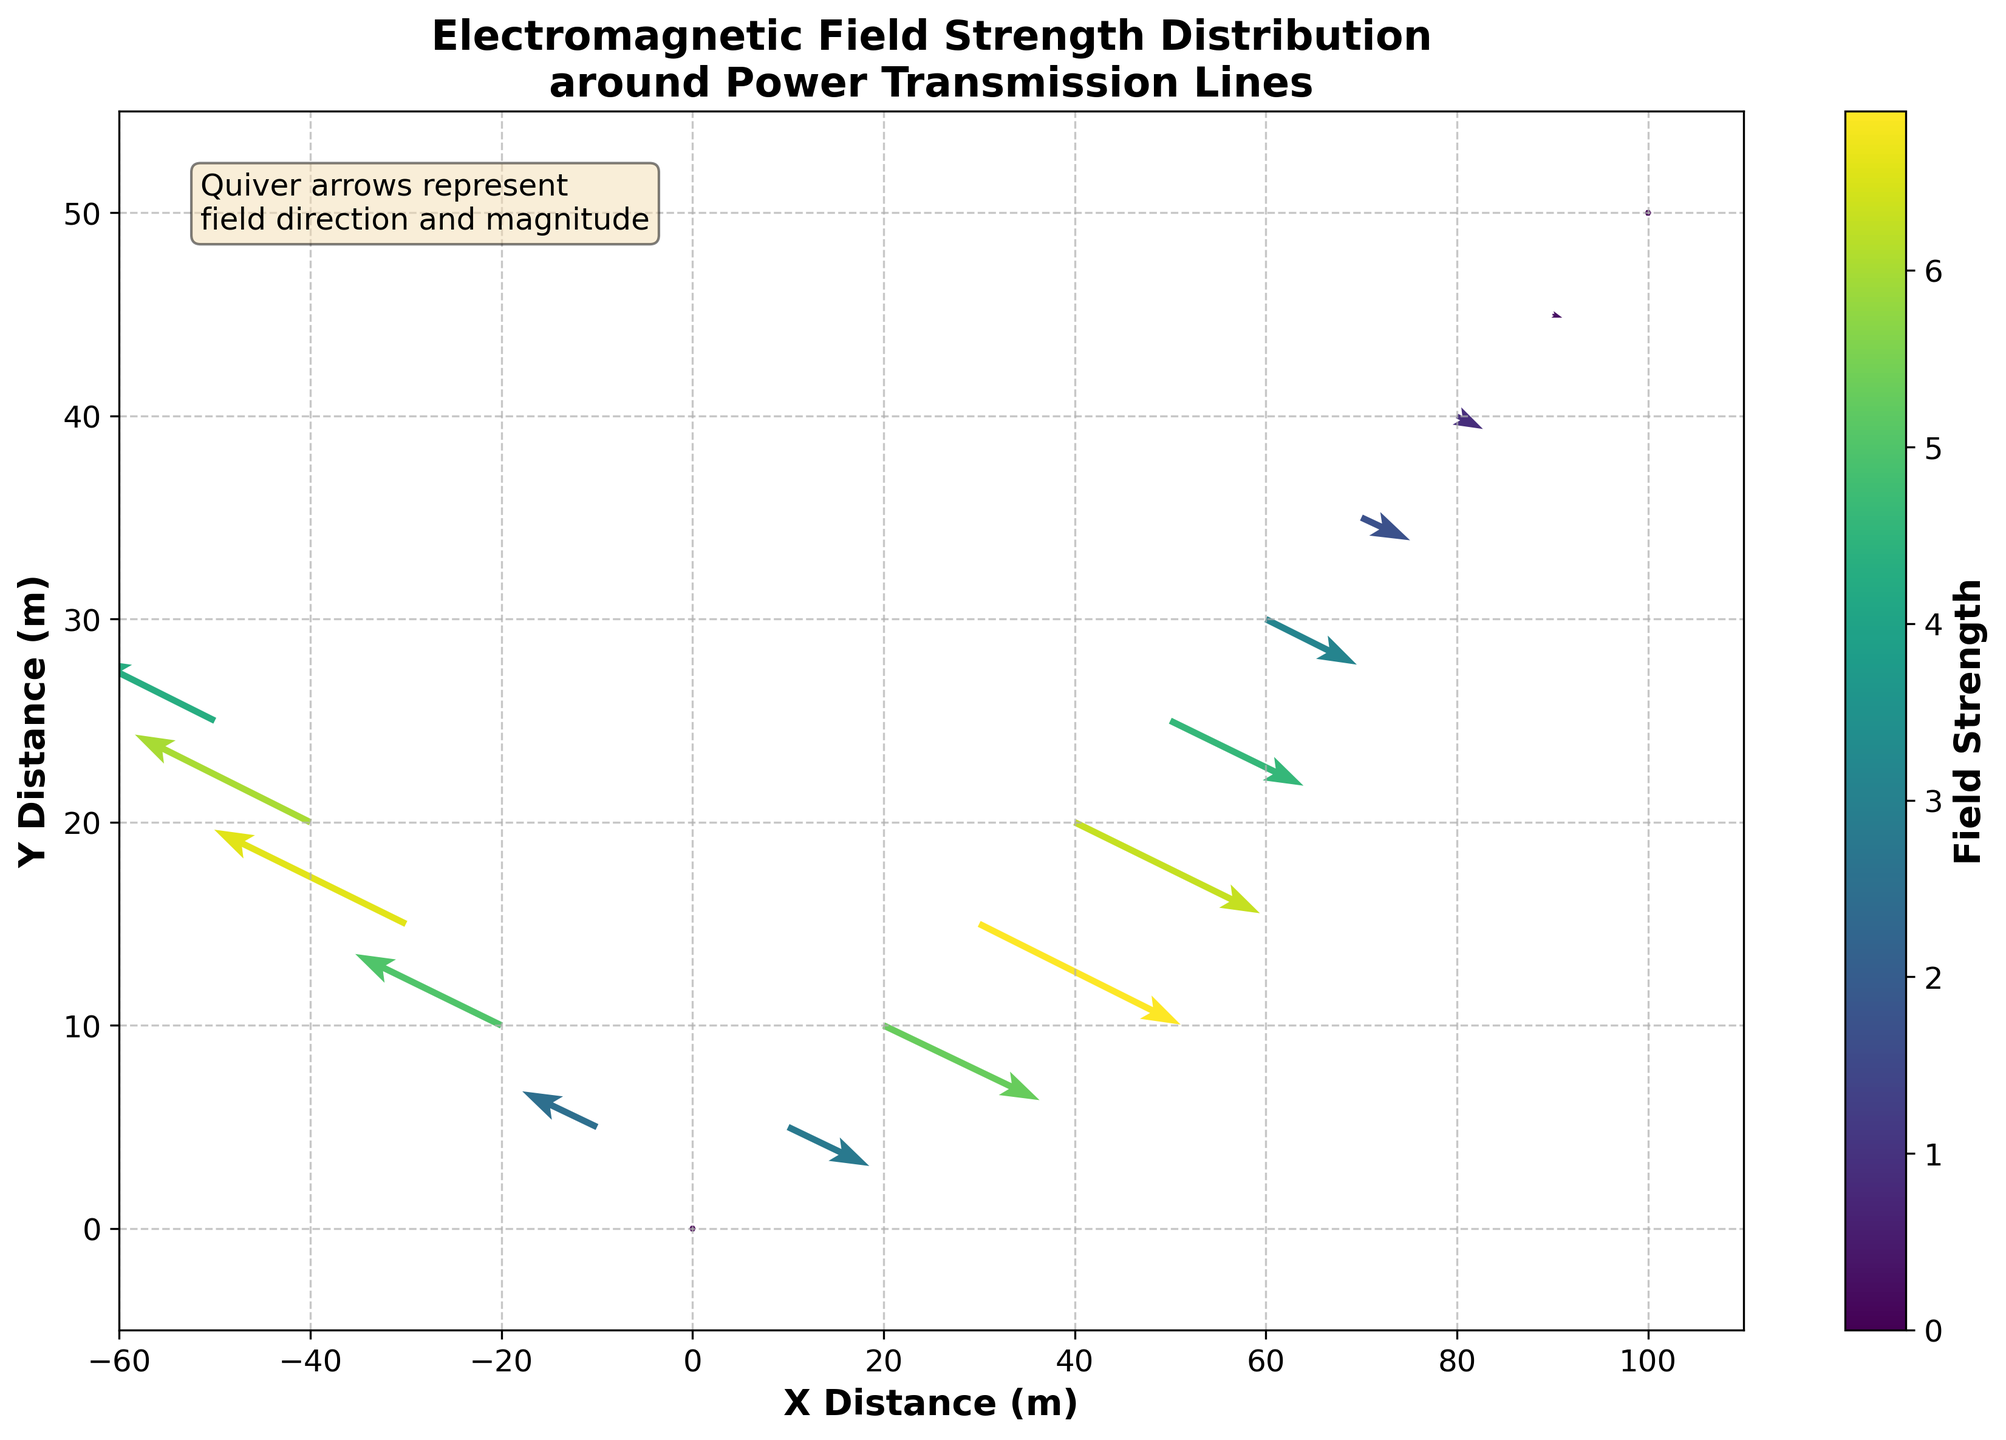What is the title of the plot? The title of the plot is positioned at the top center of the figure, usually in a larger and bold font for emphasis. It provides an overview of what the plot represents visually.
Answer: Electromagnetic Field Strength Distribution around Power Transmission Lines What do the quiver arrows represent in the plot? The text box located in the plot indicates that the quiver arrows represent both the field direction and magnitude. This information is also visually depicted as arrows with varying lengths and orientations.
Answer: Field direction and magnitude How is the field strength represented in the plot? The field strength is represented by both the color and the length of the quiver arrows. A color bar on the side of the plot indicates the range of field strength values, with different colors corresponding to different strength levels.
Answer: Color and length of arrows Which axis represents the X distance? By looking at the labels on both axes, the X distance is represented by the horizontal axis with the label "X Distance (m)".
Answer: Horizontal axis Is the field strength stronger at x = 20 m or x = 80 m? Comparing the colors of the quiver arrows at x = 20 m and x = 80 m, we see that the arrow at x = 20 m has a darker color, indicating a stronger field strength as referenced by the color bar.
Answer: x = 20 m How does the direction of the electromagnetic field change as we move from x = 10 m to x = 100 m? Initially, the direction is downwards and to the right, as indicated by the arrows at lower x values like 10 m and 20 m. As we move towards higher x values, the direction gradually changes to almost horizontal rightwards and eventually becomes very small or negligible, as shown by arrows near x = 100 m.
Answer: Gradually rightwards and diminishes What are the field strength values at the coordinates (20, 10) and (-20, 10)? To answer this, refer to the color of the arrows at these coordinates and match them with the color bar. For (20, 10), the corresponding value is the darker shade indicating a higher field strength compared to (-20, 10). Simple estimation using the color bar shows values of approximately 5.3 and 5.0 respectively.
Answer: 5.3 and 5.0 Which location has the weakest electromagnetic field strength? By examining the plot and comparing the colors of the arrows, we find that the weakest field strength is indicated by the lightest color, located at (100, 50).
Answer: (100, 50) What is the average field strength for all the given data points in the plot? To find this, we calculate the average of the field strength values provided: (0 + 2.8 + 5.3 + 6.9 + 6.3 + 4.6 + 3.1 + 1.7 + 0.9 + 0.3 + 0.1 + 2.5 + 5.0 + 6.6 + 6.0 + 4.3) / 16 = 3.6. The average field strength across all data points is approximately 3.6.
Answer: 3.6 